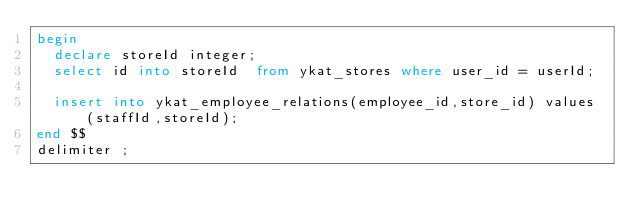<code> <loc_0><loc_0><loc_500><loc_500><_SQL_>begin
	declare storeId integer;
	select id into storeId  from ykat_stores where user_id = userId;
	
	insert into ykat_employee_relations(employee_id,store_id) values (staffId,storeId);
end $$
delimiter ;
</code> 